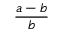Convert formula to latex. <formula><loc_0><loc_0><loc_500><loc_500>{ \frac { a - b } { b } } \,</formula> 